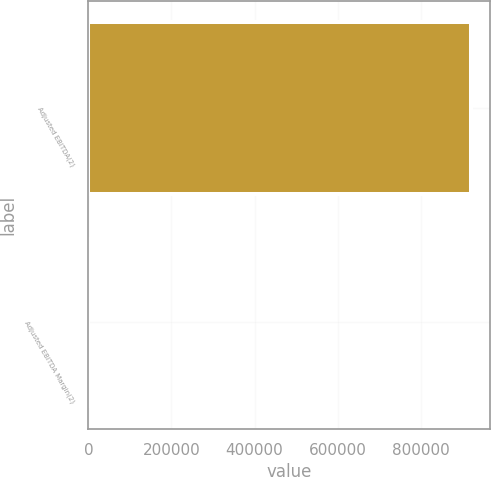<chart> <loc_0><loc_0><loc_500><loc_500><bar_chart><fcel>Adjusted EBITDA(2)<fcel>Adjusted EBITDA Margin(2)<nl><fcel>920005<fcel>30.6<nl></chart> 